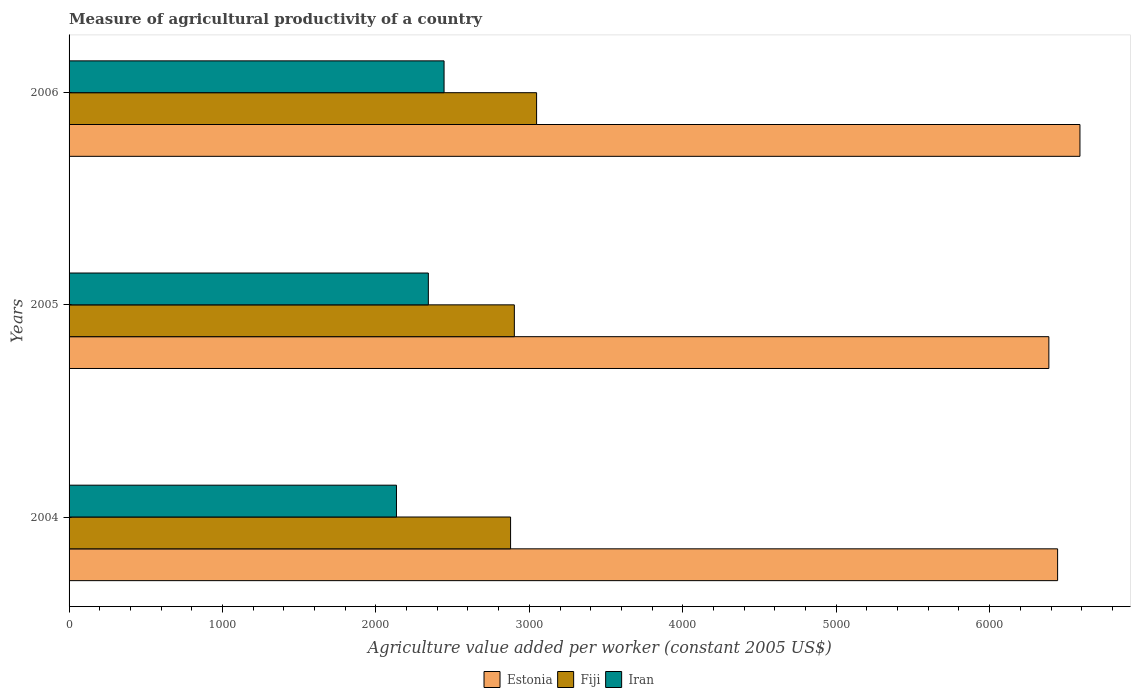How many different coloured bars are there?
Your answer should be compact. 3. How many groups of bars are there?
Provide a succinct answer. 3. How many bars are there on the 2nd tick from the top?
Ensure brevity in your answer.  3. How many bars are there on the 2nd tick from the bottom?
Offer a very short reply. 3. What is the measure of agricultural productivity in Iran in 2004?
Offer a terse response. 2133.87. Across all years, what is the maximum measure of agricultural productivity in Fiji?
Offer a very short reply. 3047.17. Across all years, what is the minimum measure of agricultural productivity in Fiji?
Offer a terse response. 2877.67. What is the total measure of agricultural productivity in Estonia in the graph?
Provide a succinct answer. 1.94e+04. What is the difference between the measure of agricultural productivity in Iran in 2004 and that in 2005?
Offer a very short reply. -207.79. What is the difference between the measure of agricultural productivity in Iran in 2004 and the measure of agricultural productivity in Fiji in 2006?
Provide a short and direct response. -913.3. What is the average measure of agricultural productivity in Fiji per year?
Your response must be concise. 2942.35. In the year 2006, what is the difference between the measure of agricultural productivity in Fiji and measure of agricultural productivity in Iran?
Offer a very short reply. 603.03. What is the ratio of the measure of agricultural productivity in Fiji in 2005 to that in 2006?
Your answer should be very brief. 0.95. What is the difference between the highest and the second highest measure of agricultural productivity in Estonia?
Offer a terse response. 145.58. What is the difference between the highest and the lowest measure of agricultural productivity in Iran?
Make the answer very short. 310.27. In how many years, is the measure of agricultural productivity in Estonia greater than the average measure of agricultural productivity in Estonia taken over all years?
Your response must be concise. 1. Is the sum of the measure of agricultural productivity in Estonia in 2004 and 2005 greater than the maximum measure of agricultural productivity in Iran across all years?
Keep it short and to the point. Yes. What does the 2nd bar from the top in 2005 represents?
Give a very brief answer. Fiji. What does the 1st bar from the bottom in 2006 represents?
Provide a succinct answer. Estonia. Is it the case that in every year, the sum of the measure of agricultural productivity in Fiji and measure of agricultural productivity in Iran is greater than the measure of agricultural productivity in Estonia?
Your answer should be very brief. No. Are all the bars in the graph horizontal?
Your answer should be compact. Yes. Are the values on the major ticks of X-axis written in scientific E-notation?
Your answer should be very brief. No. Does the graph contain grids?
Offer a very short reply. No. Where does the legend appear in the graph?
Your response must be concise. Bottom center. How many legend labels are there?
Give a very brief answer. 3. What is the title of the graph?
Keep it short and to the point. Measure of agricultural productivity of a country. What is the label or title of the X-axis?
Keep it short and to the point. Agriculture value added per worker (constant 2005 US$). What is the label or title of the Y-axis?
Offer a terse response. Years. What is the Agriculture value added per worker (constant 2005 US$) of Estonia in 2004?
Your answer should be very brief. 6443.08. What is the Agriculture value added per worker (constant 2005 US$) in Fiji in 2004?
Offer a terse response. 2877.67. What is the Agriculture value added per worker (constant 2005 US$) of Iran in 2004?
Keep it short and to the point. 2133.87. What is the Agriculture value added per worker (constant 2005 US$) of Estonia in 2005?
Your answer should be compact. 6386.02. What is the Agriculture value added per worker (constant 2005 US$) of Fiji in 2005?
Give a very brief answer. 2902.21. What is the Agriculture value added per worker (constant 2005 US$) in Iran in 2005?
Keep it short and to the point. 2341.66. What is the Agriculture value added per worker (constant 2005 US$) of Estonia in 2006?
Your answer should be very brief. 6588.66. What is the Agriculture value added per worker (constant 2005 US$) in Fiji in 2006?
Make the answer very short. 3047.17. What is the Agriculture value added per worker (constant 2005 US$) in Iran in 2006?
Provide a succinct answer. 2444.14. Across all years, what is the maximum Agriculture value added per worker (constant 2005 US$) in Estonia?
Offer a terse response. 6588.66. Across all years, what is the maximum Agriculture value added per worker (constant 2005 US$) of Fiji?
Provide a short and direct response. 3047.17. Across all years, what is the maximum Agriculture value added per worker (constant 2005 US$) of Iran?
Your answer should be very brief. 2444.14. Across all years, what is the minimum Agriculture value added per worker (constant 2005 US$) of Estonia?
Keep it short and to the point. 6386.02. Across all years, what is the minimum Agriculture value added per worker (constant 2005 US$) of Fiji?
Give a very brief answer. 2877.67. Across all years, what is the minimum Agriculture value added per worker (constant 2005 US$) in Iran?
Your response must be concise. 2133.87. What is the total Agriculture value added per worker (constant 2005 US$) of Estonia in the graph?
Ensure brevity in your answer.  1.94e+04. What is the total Agriculture value added per worker (constant 2005 US$) of Fiji in the graph?
Your answer should be compact. 8827.05. What is the total Agriculture value added per worker (constant 2005 US$) in Iran in the graph?
Offer a very short reply. 6919.68. What is the difference between the Agriculture value added per worker (constant 2005 US$) of Estonia in 2004 and that in 2005?
Make the answer very short. 57.06. What is the difference between the Agriculture value added per worker (constant 2005 US$) of Fiji in 2004 and that in 2005?
Give a very brief answer. -24.54. What is the difference between the Agriculture value added per worker (constant 2005 US$) of Iran in 2004 and that in 2005?
Your answer should be very brief. -207.79. What is the difference between the Agriculture value added per worker (constant 2005 US$) of Estonia in 2004 and that in 2006?
Offer a very short reply. -145.58. What is the difference between the Agriculture value added per worker (constant 2005 US$) of Fiji in 2004 and that in 2006?
Your answer should be very brief. -169.5. What is the difference between the Agriculture value added per worker (constant 2005 US$) of Iran in 2004 and that in 2006?
Make the answer very short. -310.27. What is the difference between the Agriculture value added per worker (constant 2005 US$) of Estonia in 2005 and that in 2006?
Give a very brief answer. -202.64. What is the difference between the Agriculture value added per worker (constant 2005 US$) of Fiji in 2005 and that in 2006?
Make the answer very short. -144.97. What is the difference between the Agriculture value added per worker (constant 2005 US$) in Iran in 2005 and that in 2006?
Offer a terse response. -102.48. What is the difference between the Agriculture value added per worker (constant 2005 US$) of Estonia in 2004 and the Agriculture value added per worker (constant 2005 US$) of Fiji in 2005?
Make the answer very short. 3540.87. What is the difference between the Agriculture value added per worker (constant 2005 US$) of Estonia in 2004 and the Agriculture value added per worker (constant 2005 US$) of Iran in 2005?
Ensure brevity in your answer.  4101.42. What is the difference between the Agriculture value added per worker (constant 2005 US$) in Fiji in 2004 and the Agriculture value added per worker (constant 2005 US$) in Iran in 2005?
Make the answer very short. 536.01. What is the difference between the Agriculture value added per worker (constant 2005 US$) of Estonia in 2004 and the Agriculture value added per worker (constant 2005 US$) of Fiji in 2006?
Your response must be concise. 3395.91. What is the difference between the Agriculture value added per worker (constant 2005 US$) of Estonia in 2004 and the Agriculture value added per worker (constant 2005 US$) of Iran in 2006?
Provide a succinct answer. 3998.93. What is the difference between the Agriculture value added per worker (constant 2005 US$) of Fiji in 2004 and the Agriculture value added per worker (constant 2005 US$) of Iran in 2006?
Your answer should be compact. 433.53. What is the difference between the Agriculture value added per worker (constant 2005 US$) in Estonia in 2005 and the Agriculture value added per worker (constant 2005 US$) in Fiji in 2006?
Keep it short and to the point. 3338.85. What is the difference between the Agriculture value added per worker (constant 2005 US$) in Estonia in 2005 and the Agriculture value added per worker (constant 2005 US$) in Iran in 2006?
Your response must be concise. 3941.88. What is the difference between the Agriculture value added per worker (constant 2005 US$) in Fiji in 2005 and the Agriculture value added per worker (constant 2005 US$) in Iran in 2006?
Keep it short and to the point. 458.06. What is the average Agriculture value added per worker (constant 2005 US$) in Estonia per year?
Make the answer very short. 6472.59. What is the average Agriculture value added per worker (constant 2005 US$) in Fiji per year?
Ensure brevity in your answer.  2942.35. What is the average Agriculture value added per worker (constant 2005 US$) of Iran per year?
Ensure brevity in your answer.  2306.56. In the year 2004, what is the difference between the Agriculture value added per worker (constant 2005 US$) of Estonia and Agriculture value added per worker (constant 2005 US$) of Fiji?
Ensure brevity in your answer.  3565.41. In the year 2004, what is the difference between the Agriculture value added per worker (constant 2005 US$) of Estonia and Agriculture value added per worker (constant 2005 US$) of Iran?
Your answer should be very brief. 4309.21. In the year 2004, what is the difference between the Agriculture value added per worker (constant 2005 US$) of Fiji and Agriculture value added per worker (constant 2005 US$) of Iran?
Give a very brief answer. 743.8. In the year 2005, what is the difference between the Agriculture value added per worker (constant 2005 US$) in Estonia and Agriculture value added per worker (constant 2005 US$) in Fiji?
Keep it short and to the point. 3483.82. In the year 2005, what is the difference between the Agriculture value added per worker (constant 2005 US$) of Estonia and Agriculture value added per worker (constant 2005 US$) of Iran?
Ensure brevity in your answer.  4044.36. In the year 2005, what is the difference between the Agriculture value added per worker (constant 2005 US$) of Fiji and Agriculture value added per worker (constant 2005 US$) of Iran?
Offer a terse response. 560.55. In the year 2006, what is the difference between the Agriculture value added per worker (constant 2005 US$) of Estonia and Agriculture value added per worker (constant 2005 US$) of Fiji?
Make the answer very short. 3541.49. In the year 2006, what is the difference between the Agriculture value added per worker (constant 2005 US$) in Estonia and Agriculture value added per worker (constant 2005 US$) in Iran?
Provide a succinct answer. 4144.51. In the year 2006, what is the difference between the Agriculture value added per worker (constant 2005 US$) of Fiji and Agriculture value added per worker (constant 2005 US$) of Iran?
Give a very brief answer. 603.03. What is the ratio of the Agriculture value added per worker (constant 2005 US$) in Estonia in 2004 to that in 2005?
Your answer should be very brief. 1.01. What is the ratio of the Agriculture value added per worker (constant 2005 US$) of Iran in 2004 to that in 2005?
Provide a succinct answer. 0.91. What is the ratio of the Agriculture value added per worker (constant 2005 US$) of Estonia in 2004 to that in 2006?
Provide a succinct answer. 0.98. What is the ratio of the Agriculture value added per worker (constant 2005 US$) of Fiji in 2004 to that in 2006?
Keep it short and to the point. 0.94. What is the ratio of the Agriculture value added per worker (constant 2005 US$) in Iran in 2004 to that in 2006?
Make the answer very short. 0.87. What is the ratio of the Agriculture value added per worker (constant 2005 US$) in Estonia in 2005 to that in 2006?
Offer a very short reply. 0.97. What is the ratio of the Agriculture value added per worker (constant 2005 US$) in Iran in 2005 to that in 2006?
Ensure brevity in your answer.  0.96. What is the difference between the highest and the second highest Agriculture value added per worker (constant 2005 US$) in Estonia?
Provide a short and direct response. 145.58. What is the difference between the highest and the second highest Agriculture value added per worker (constant 2005 US$) in Fiji?
Your response must be concise. 144.97. What is the difference between the highest and the second highest Agriculture value added per worker (constant 2005 US$) in Iran?
Offer a terse response. 102.48. What is the difference between the highest and the lowest Agriculture value added per worker (constant 2005 US$) of Estonia?
Offer a very short reply. 202.64. What is the difference between the highest and the lowest Agriculture value added per worker (constant 2005 US$) in Fiji?
Provide a succinct answer. 169.5. What is the difference between the highest and the lowest Agriculture value added per worker (constant 2005 US$) of Iran?
Provide a short and direct response. 310.27. 